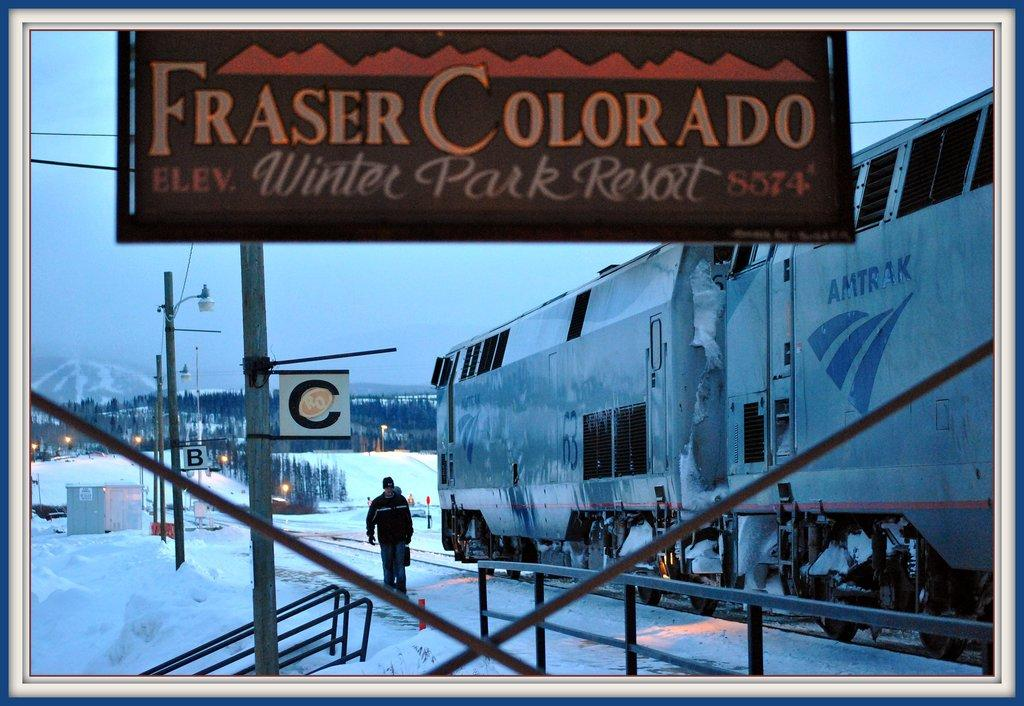<image>
Describe the image concisely. An outdoor billboard titled Fraser Colorado on it. 